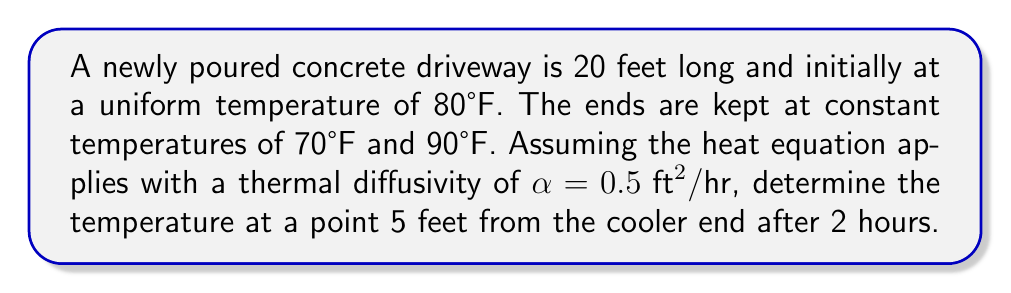What is the answer to this math problem? To solve this problem, we'll use the one-dimensional heat equation:

$$\frac{\partial u}{\partial t} = \alpha \frac{\partial^2 u}{\partial x^2}$$

Given:
- Length $L = 20 \text{ ft}$
- Initial temperature $u(x,0) = 80°F$
- Boundary conditions: $u(0,t) = 70°F$, $u(20,t) = 90°F$
- $\alpha = 0.5 \text{ ft}^2/\text{hr}$
- Point of interest: $x = 5 \text{ ft}$, $t = 2 \text{ hr}$

Step 1: The solution to this problem is given by the series:

$$u(x,t) = 70 + x + \sum_{n=1}^{\infty} B_n \sin(\frac{n\pi x}{L}) e^{-(\frac{n\pi}{L})^2 \alpha t}$$

where $B_n = \frac{2}{L} \int_0^L [u(x,0) - (70 + x)] \sin(\frac{n\pi x}{L}) dx$

Step 2: Calculate $B_n$:
$$B_n = \frac{2}{20} \int_0^{20} [80 - (70 + x)] \sin(\frac{n\pi x}{20}) dx = \frac{400}{n\pi} (1 - \cos(n\pi))$$

Step 3: Substitute values into the series solution:
$$u(5,2) = 70 + 5 + \sum_{n=1}^{\infty} \frac{400}{n\pi} (1 - \cos(n\pi)) \sin(\frac{n\pi 5}{20}) e^{-(\frac{n\pi}{20})^2 0.5 \cdot 2}$$

Step 4: Evaluate the series numerically (using software or a calculator) for a sufficient number of terms to achieve desired accuracy.
Answer: $u(5,2) \approx 77.8°F$ 